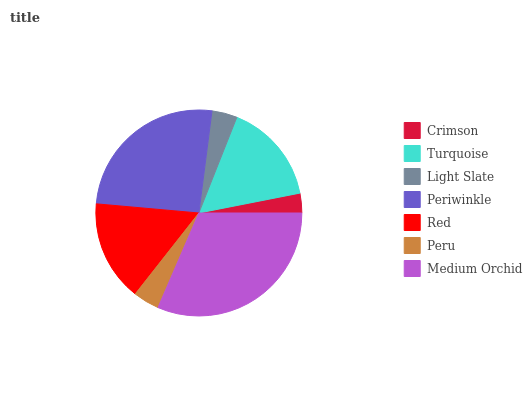Is Crimson the minimum?
Answer yes or no. Yes. Is Medium Orchid the maximum?
Answer yes or no. Yes. Is Turquoise the minimum?
Answer yes or no. No. Is Turquoise the maximum?
Answer yes or no. No. Is Turquoise greater than Crimson?
Answer yes or no. Yes. Is Crimson less than Turquoise?
Answer yes or no. Yes. Is Crimson greater than Turquoise?
Answer yes or no. No. Is Turquoise less than Crimson?
Answer yes or no. No. Is Red the high median?
Answer yes or no. Yes. Is Red the low median?
Answer yes or no. Yes. Is Light Slate the high median?
Answer yes or no. No. Is Medium Orchid the low median?
Answer yes or no. No. 